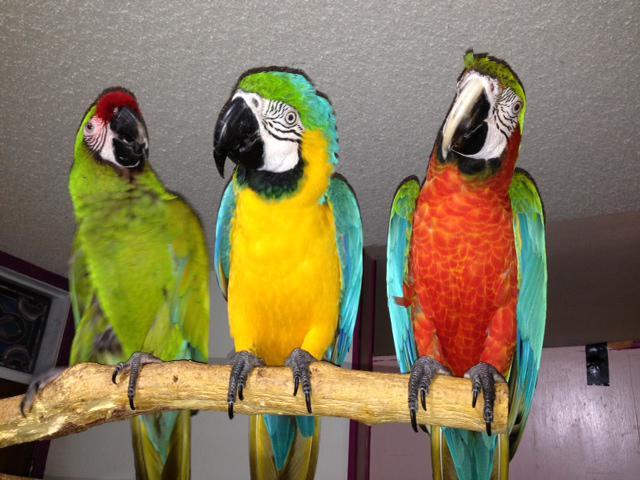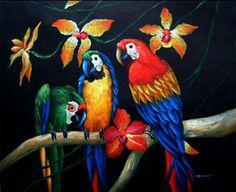The first image is the image on the left, the second image is the image on the right. For the images shown, is this caption "Each image shows a row of three birds perched on a branch, and no row of birds all share the same coloring." true? Answer yes or no. Yes. 